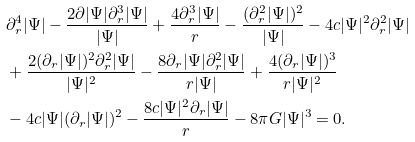Convert formula to latex. <formula><loc_0><loc_0><loc_500><loc_500>& \partial _ { r } ^ { 4 } | \Psi | - \frac { 2 \partial | \Psi | \partial _ { r } ^ { 3 } | \Psi | } { | \Psi | } + \frac { 4 \partial _ { r } ^ { 3 } | \Psi | } { r } - \frac { ( \partial _ { r } ^ { 2 } | \Psi | ) ^ { 2 } } { | \Psi | } - 4 c | \Psi | ^ { 2 } \partial _ { r } ^ { 2 } | \Psi | \\ & + \frac { 2 ( \partial _ { r } | \Psi | ) ^ { 2 } \partial _ { r } ^ { 2 } | \Psi | } { | \Psi | ^ { 2 } } - \frac { 8 \partial _ { r } | \Psi | \partial _ { r } ^ { 2 } | \Psi | } { r | \Psi | } + \frac { 4 ( \partial _ { r } | \Psi | ) ^ { 3 } } { r | \Psi | ^ { 2 } } \\ & - 4 c | \Psi | ( \partial _ { r } | \Psi | ) ^ { 2 } - \frac { 8 c | \Psi | ^ { 2 } \partial _ { r } | \Psi | } { r } - 8 \pi G | \Psi | ^ { 3 } = 0 .</formula> 